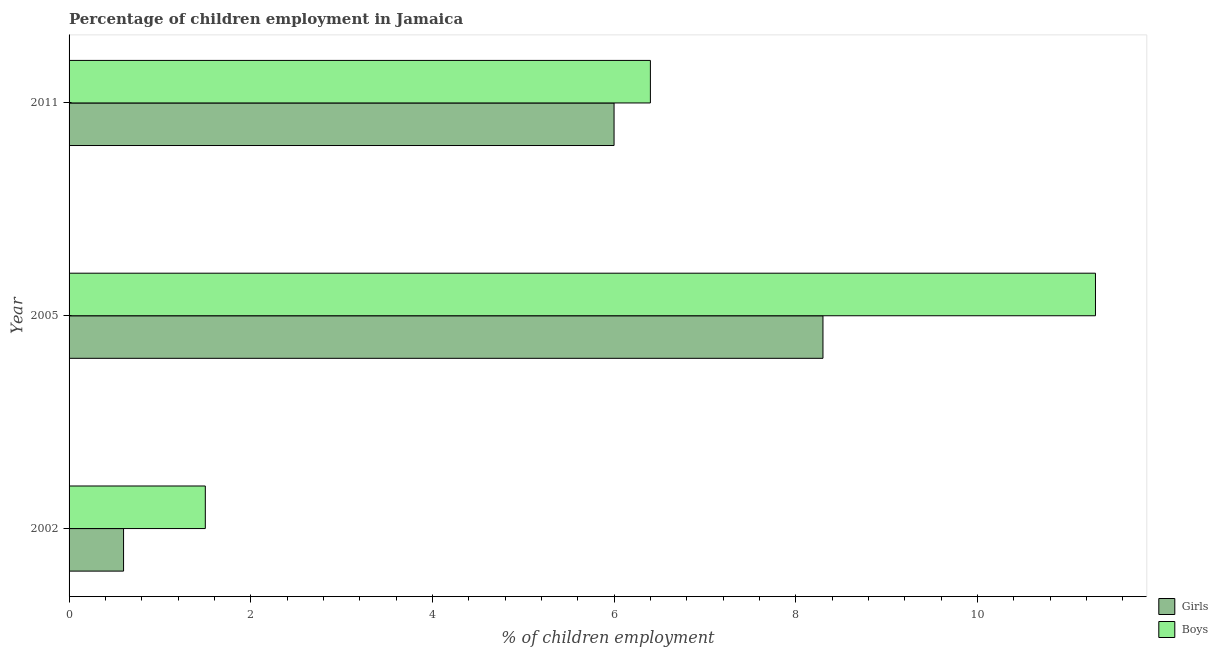How many different coloured bars are there?
Provide a succinct answer. 2. How many bars are there on the 1st tick from the top?
Your answer should be compact. 2. How many bars are there on the 1st tick from the bottom?
Give a very brief answer. 2. In how many cases, is the number of bars for a given year not equal to the number of legend labels?
Offer a terse response. 0. What is the percentage of employed boys in 2011?
Your answer should be compact. 6.4. Across all years, what is the maximum percentage of employed boys?
Make the answer very short. 11.3. In which year was the percentage of employed girls maximum?
Offer a very short reply. 2005. What is the total percentage of employed boys in the graph?
Keep it short and to the point. 19.2. What is the difference between the percentage of employed girls in 2005 and that in 2011?
Your response must be concise. 2.3. What is the average percentage of employed girls per year?
Make the answer very short. 4.97. In how many years, is the percentage of employed girls greater than 10.8 %?
Give a very brief answer. 0. What is the ratio of the percentage of employed girls in 2005 to that in 2011?
Ensure brevity in your answer.  1.38. Is the percentage of employed girls in 2002 less than that in 2005?
Offer a terse response. Yes. Is the difference between the percentage of employed boys in 2002 and 2005 greater than the difference between the percentage of employed girls in 2002 and 2005?
Provide a short and direct response. No. Is the sum of the percentage of employed boys in 2002 and 2005 greater than the maximum percentage of employed girls across all years?
Ensure brevity in your answer.  Yes. What does the 2nd bar from the top in 2002 represents?
Offer a terse response. Girls. What does the 2nd bar from the bottom in 2002 represents?
Offer a very short reply. Boys. Are the values on the major ticks of X-axis written in scientific E-notation?
Offer a very short reply. No. Does the graph contain grids?
Offer a very short reply. No. What is the title of the graph?
Make the answer very short. Percentage of children employment in Jamaica. What is the label or title of the X-axis?
Give a very brief answer. % of children employment. What is the % of children employment of Boys in 2002?
Provide a short and direct response. 1.5. Across all years, what is the minimum % of children employment in Boys?
Provide a short and direct response. 1.5. What is the difference between the % of children employment in Boys in 2002 and that in 2005?
Your response must be concise. -9.8. What is the difference between the % of children employment in Girls in 2002 and that in 2011?
Your answer should be compact. -5.4. What is the difference between the % of children employment of Girls in 2002 and the % of children employment of Boys in 2005?
Your response must be concise. -10.7. What is the difference between the % of children employment in Girls in 2002 and the % of children employment in Boys in 2011?
Your answer should be compact. -5.8. What is the average % of children employment of Girls per year?
Keep it short and to the point. 4.97. What is the average % of children employment in Boys per year?
Give a very brief answer. 6.4. In the year 2002, what is the difference between the % of children employment in Girls and % of children employment in Boys?
Give a very brief answer. -0.9. In the year 2005, what is the difference between the % of children employment of Girls and % of children employment of Boys?
Provide a short and direct response. -3. In the year 2011, what is the difference between the % of children employment of Girls and % of children employment of Boys?
Your answer should be very brief. -0.4. What is the ratio of the % of children employment of Girls in 2002 to that in 2005?
Your answer should be very brief. 0.07. What is the ratio of the % of children employment of Boys in 2002 to that in 2005?
Offer a very short reply. 0.13. What is the ratio of the % of children employment of Boys in 2002 to that in 2011?
Offer a very short reply. 0.23. What is the ratio of the % of children employment in Girls in 2005 to that in 2011?
Make the answer very short. 1.38. What is the ratio of the % of children employment of Boys in 2005 to that in 2011?
Your answer should be compact. 1.77. What is the difference between the highest and the second highest % of children employment in Boys?
Give a very brief answer. 4.9. 